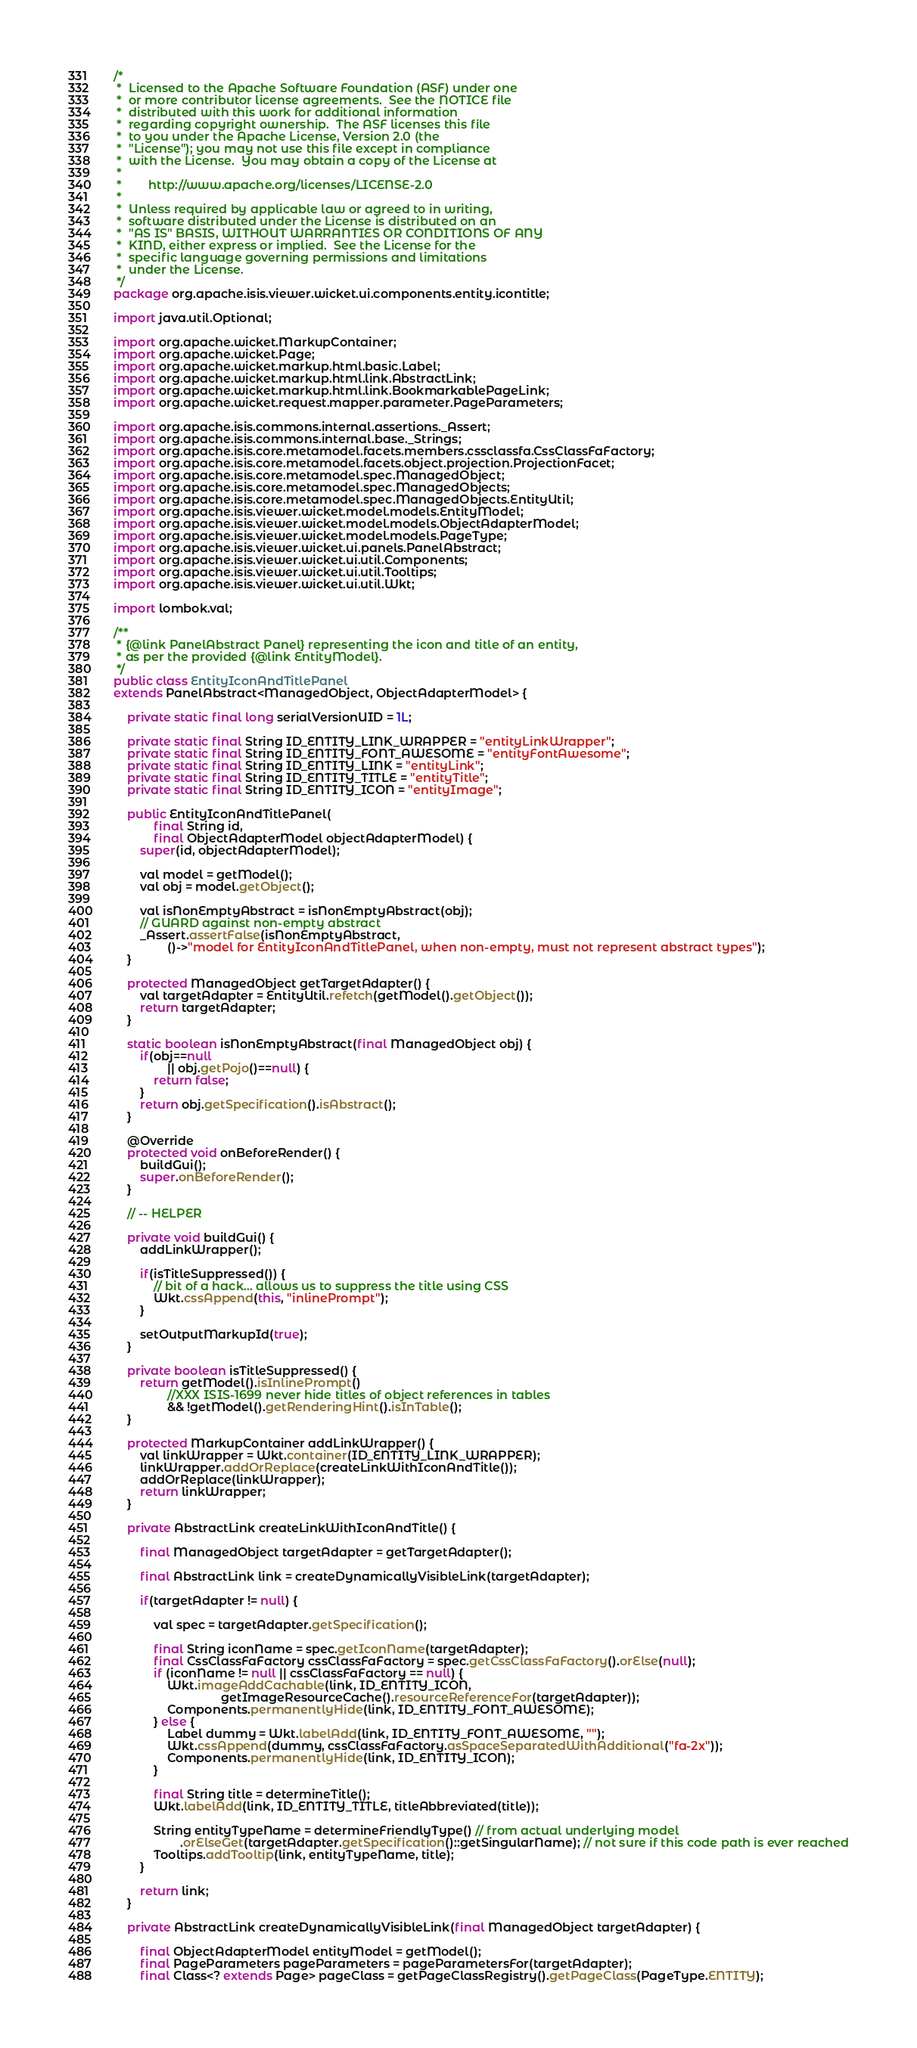Convert code to text. <code><loc_0><loc_0><loc_500><loc_500><_Java_>/*
 *  Licensed to the Apache Software Foundation (ASF) under one
 *  or more contributor license agreements.  See the NOTICE file
 *  distributed with this work for additional information
 *  regarding copyright ownership.  The ASF licenses this file
 *  to you under the Apache License, Version 2.0 (the
 *  "License"); you may not use this file except in compliance
 *  with the License.  You may obtain a copy of the License at
 *
 *        http://www.apache.org/licenses/LICENSE-2.0
 *
 *  Unless required by applicable law or agreed to in writing,
 *  software distributed under the License is distributed on an
 *  "AS IS" BASIS, WITHOUT WARRANTIES OR CONDITIONS OF ANY
 *  KIND, either express or implied.  See the License for the
 *  specific language governing permissions and limitations
 *  under the License.
 */
package org.apache.isis.viewer.wicket.ui.components.entity.icontitle;

import java.util.Optional;

import org.apache.wicket.MarkupContainer;
import org.apache.wicket.Page;
import org.apache.wicket.markup.html.basic.Label;
import org.apache.wicket.markup.html.link.AbstractLink;
import org.apache.wicket.markup.html.link.BookmarkablePageLink;
import org.apache.wicket.request.mapper.parameter.PageParameters;

import org.apache.isis.commons.internal.assertions._Assert;
import org.apache.isis.commons.internal.base._Strings;
import org.apache.isis.core.metamodel.facets.members.cssclassfa.CssClassFaFactory;
import org.apache.isis.core.metamodel.facets.object.projection.ProjectionFacet;
import org.apache.isis.core.metamodel.spec.ManagedObject;
import org.apache.isis.core.metamodel.spec.ManagedObjects;
import org.apache.isis.core.metamodel.spec.ManagedObjects.EntityUtil;
import org.apache.isis.viewer.wicket.model.models.EntityModel;
import org.apache.isis.viewer.wicket.model.models.ObjectAdapterModel;
import org.apache.isis.viewer.wicket.model.models.PageType;
import org.apache.isis.viewer.wicket.ui.panels.PanelAbstract;
import org.apache.isis.viewer.wicket.ui.util.Components;
import org.apache.isis.viewer.wicket.ui.util.Tooltips;
import org.apache.isis.viewer.wicket.ui.util.Wkt;

import lombok.val;

/**
 * {@link PanelAbstract Panel} representing the icon and title of an entity,
 * as per the provided {@link EntityModel}.
 */
public class EntityIconAndTitlePanel
extends PanelAbstract<ManagedObject, ObjectAdapterModel> {

    private static final long serialVersionUID = 1L;

    private static final String ID_ENTITY_LINK_WRAPPER = "entityLinkWrapper";
    private static final String ID_ENTITY_FONT_AWESOME = "entityFontAwesome";
    private static final String ID_ENTITY_LINK = "entityLink";
    private static final String ID_ENTITY_TITLE = "entityTitle";
    private static final String ID_ENTITY_ICON = "entityImage";

    public EntityIconAndTitlePanel(
            final String id,
            final ObjectAdapterModel objectAdapterModel) {
        super(id, objectAdapterModel);

        val model = getModel();
        val obj = model.getObject();

        val isNonEmptyAbstract = isNonEmptyAbstract(obj);
        // GUARD against non-empty abstract
        _Assert.assertFalse(isNonEmptyAbstract,
                ()->"model for EntityIconAndTitlePanel, when non-empty, must not represent abstract types");
    }

    protected ManagedObject getTargetAdapter() {
        val targetAdapter = EntityUtil.refetch(getModel().getObject());
        return targetAdapter;
    }

    static boolean isNonEmptyAbstract(final ManagedObject obj) {
        if(obj==null
                || obj.getPojo()==null) {
            return false;
        }
        return obj.getSpecification().isAbstract();
    }

    @Override
    protected void onBeforeRender() {
        buildGui();
        super.onBeforeRender();
    }

    // -- HELPER

    private void buildGui() {
        addLinkWrapper();

        if(isTitleSuppressed()) {
            // bit of a hack... allows us to suppress the title using CSS
            Wkt.cssAppend(this, "inlinePrompt");
        }

        setOutputMarkupId(true);
    }

    private boolean isTitleSuppressed() {
        return getModel().isInlinePrompt()
                //XXX ISIS-1699 never hide titles of object references in tables
                && !getModel().getRenderingHint().isInTable();
    }

    protected MarkupContainer addLinkWrapper() {
        val linkWrapper = Wkt.container(ID_ENTITY_LINK_WRAPPER);
        linkWrapper.addOrReplace(createLinkWithIconAndTitle());
        addOrReplace(linkWrapper);
        return linkWrapper;
    }

    private AbstractLink createLinkWithIconAndTitle() {

        final ManagedObject targetAdapter = getTargetAdapter();

        final AbstractLink link = createDynamicallyVisibleLink(targetAdapter);

        if(targetAdapter != null) {

            val spec = targetAdapter.getSpecification();

            final String iconName = spec.getIconName(targetAdapter);
            final CssClassFaFactory cssClassFaFactory = spec.getCssClassFaFactory().orElse(null);
            if (iconName != null || cssClassFaFactory == null) {
                Wkt.imageAddCachable(link, ID_ENTITY_ICON,
                                getImageResourceCache().resourceReferenceFor(targetAdapter));
                Components.permanentlyHide(link, ID_ENTITY_FONT_AWESOME);
            } else {
                Label dummy = Wkt.labelAdd(link, ID_ENTITY_FONT_AWESOME, "");
                Wkt.cssAppend(dummy, cssClassFaFactory.asSpaceSeparatedWithAdditional("fa-2x"));
                Components.permanentlyHide(link, ID_ENTITY_ICON);
            }

            final String title = determineTitle();
            Wkt.labelAdd(link, ID_ENTITY_TITLE, titleAbbreviated(title));

            String entityTypeName = determineFriendlyType() // from actual underlying model
                    .orElseGet(targetAdapter.getSpecification()::getSingularName); // not sure if this code path is ever reached
            Tooltips.addTooltip(link, entityTypeName, title);
        }

        return link;
    }

    private AbstractLink createDynamicallyVisibleLink(final ManagedObject targetAdapter) {

        final ObjectAdapterModel entityModel = getModel();
        final PageParameters pageParameters = pageParametersFor(targetAdapter);
        final Class<? extends Page> pageClass = getPageClassRegistry().getPageClass(PageType.ENTITY);
</code> 